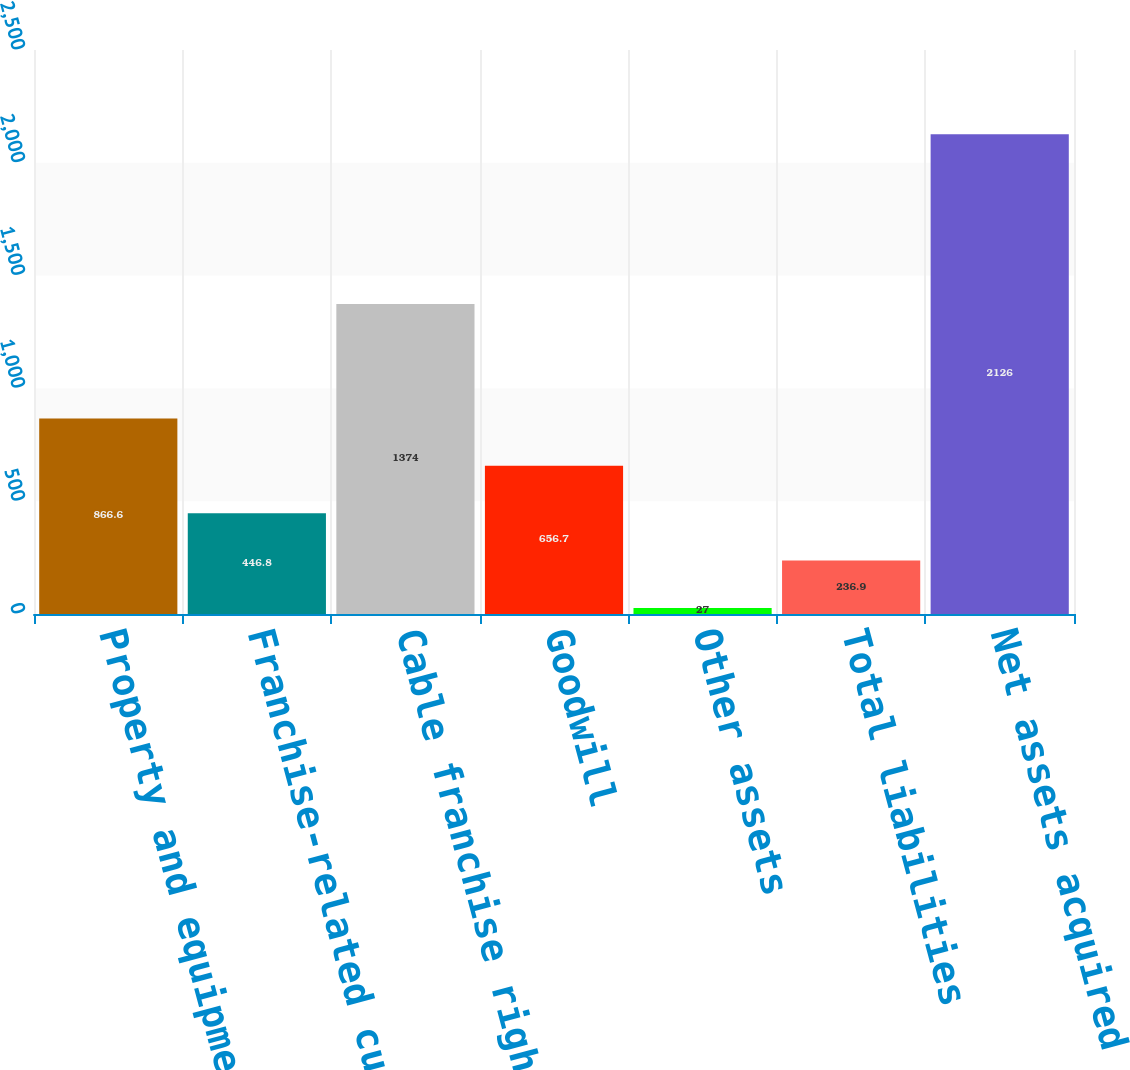Convert chart. <chart><loc_0><loc_0><loc_500><loc_500><bar_chart><fcel>Property and equipment<fcel>Franchise-related customer<fcel>Cable franchise rights<fcel>Goodwill<fcel>Other assets<fcel>Total liabilities<fcel>Net assets acquired<nl><fcel>866.6<fcel>446.8<fcel>1374<fcel>656.7<fcel>27<fcel>236.9<fcel>2126<nl></chart> 